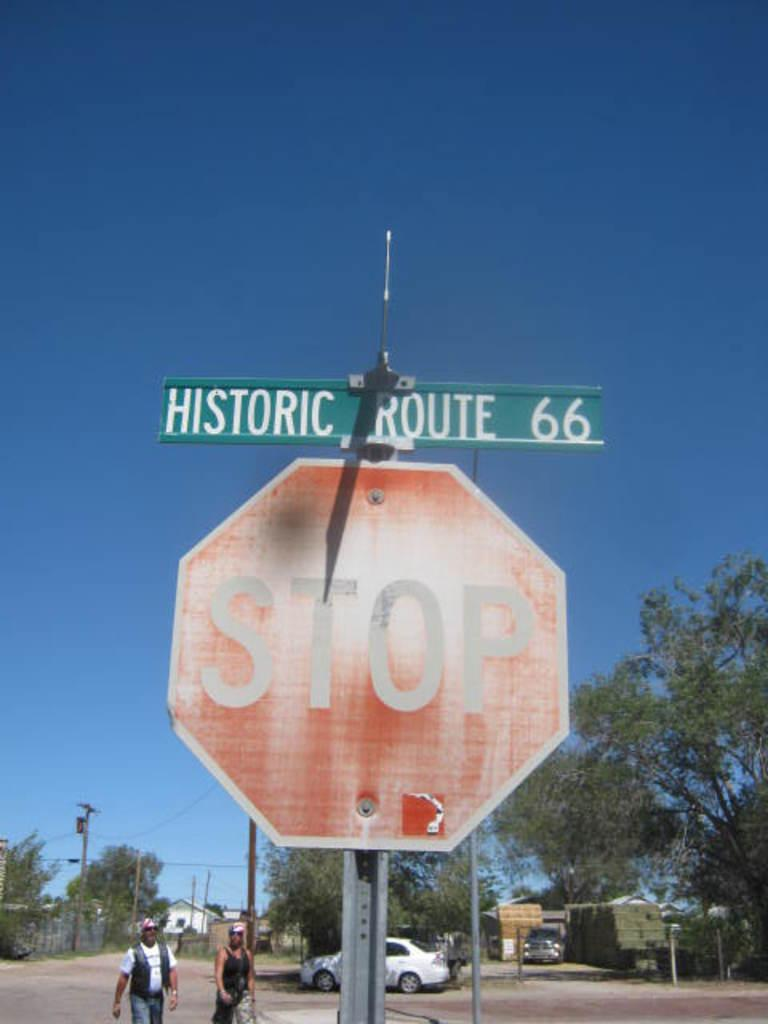<image>
Write a terse but informative summary of the picture. A faded stop sign has a street sign above it that says Historic Route 66. 